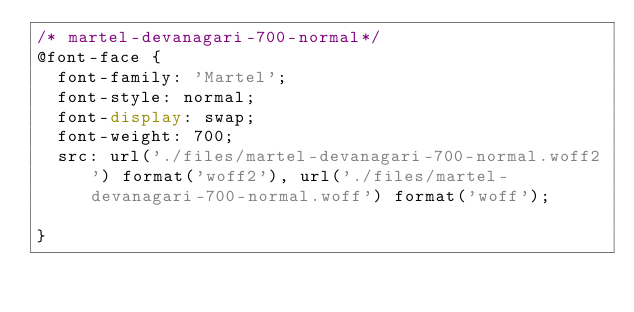Convert code to text. <code><loc_0><loc_0><loc_500><loc_500><_CSS_>/* martel-devanagari-700-normal*/
@font-face {
  font-family: 'Martel';
  font-style: normal;
  font-display: swap;
  font-weight: 700;
  src: url('./files/martel-devanagari-700-normal.woff2') format('woff2'), url('./files/martel-devanagari-700-normal.woff') format('woff');
  
}
</code> 